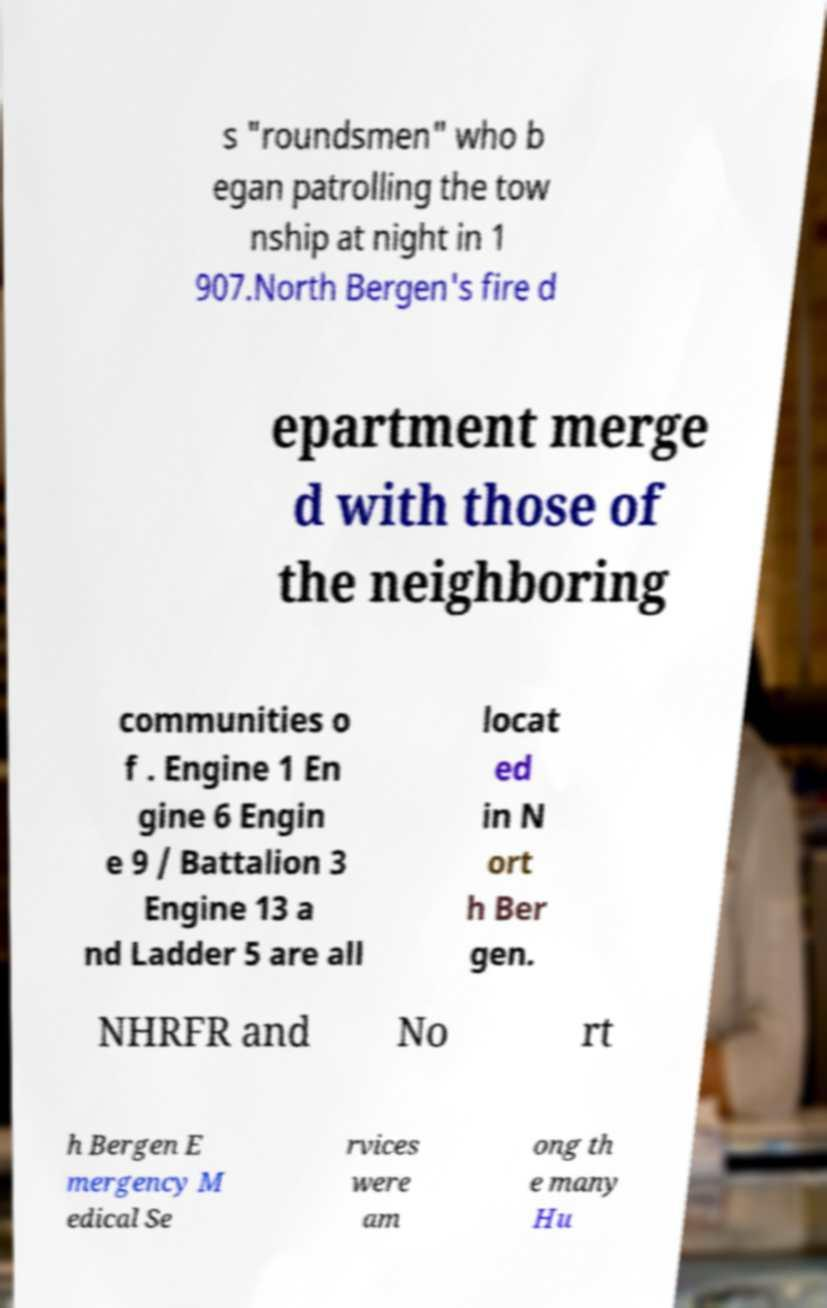Can you accurately transcribe the text from the provided image for me? s "roundsmen" who b egan patrolling the tow nship at night in 1 907.North Bergen's fire d epartment merge d with those of the neighboring communities o f . Engine 1 En gine 6 Engin e 9 / Battalion 3 Engine 13 a nd Ladder 5 are all locat ed in N ort h Ber gen. NHRFR and No rt h Bergen E mergency M edical Se rvices were am ong th e many Hu 